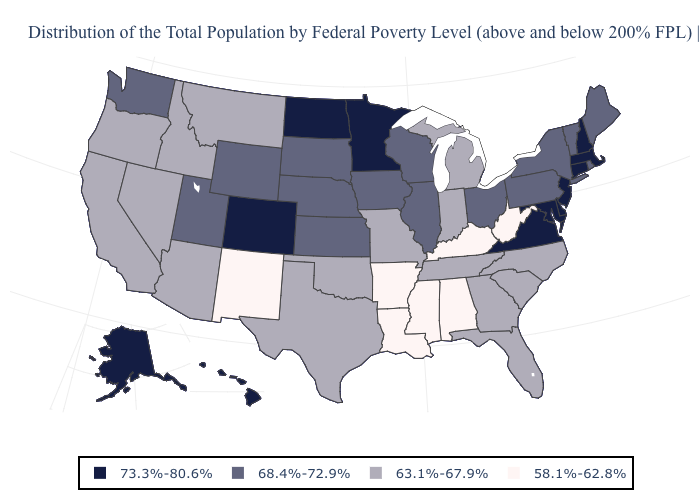Among the states that border Florida , does Alabama have the lowest value?
Short answer required. Yes. Does Virginia have a higher value than West Virginia?
Keep it brief. Yes. What is the value of Wisconsin?
Quick response, please. 68.4%-72.9%. Among the states that border Montana , does Wyoming have the lowest value?
Quick response, please. No. Does Minnesota have a higher value than Alabama?
Short answer required. Yes. Name the states that have a value in the range 63.1%-67.9%?
Give a very brief answer. Arizona, California, Florida, Georgia, Idaho, Indiana, Michigan, Missouri, Montana, Nevada, North Carolina, Oklahoma, Oregon, South Carolina, Tennessee, Texas. Does Louisiana have a lower value than Connecticut?
Quick response, please. Yes. What is the value of Georgia?
Answer briefly. 63.1%-67.9%. Among the states that border New Mexico , which have the lowest value?
Short answer required. Arizona, Oklahoma, Texas. What is the highest value in the South ?
Quick response, please. 73.3%-80.6%. Name the states that have a value in the range 68.4%-72.9%?
Concise answer only. Illinois, Iowa, Kansas, Maine, Nebraska, New York, Ohio, Pennsylvania, Rhode Island, South Dakota, Utah, Vermont, Washington, Wisconsin, Wyoming. What is the value of Virginia?
Short answer required. 73.3%-80.6%. Which states have the lowest value in the USA?
Concise answer only. Alabama, Arkansas, Kentucky, Louisiana, Mississippi, New Mexico, West Virginia. Does California have the lowest value in the West?
Concise answer only. No. 